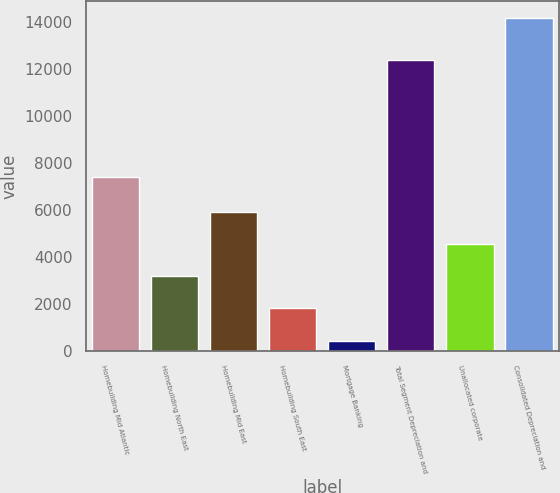Convert chart. <chart><loc_0><loc_0><loc_500><loc_500><bar_chart><fcel>Homebuilding Mid Atlantic<fcel>Homebuilding North East<fcel>Homebuilding Mid East<fcel>Homebuilding South East<fcel>Mortgage Banking<fcel>Total Segment Depreciation and<fcel>Unallocated corporate<fcel>Consolidated Depreciation and<nl><fcel>7410<fcel>3180.4<fcel>5924.8<fcel>1808.2<fcel>436<fcel>12365<fcel>4552.6<fcel>14158<nl></chart> 